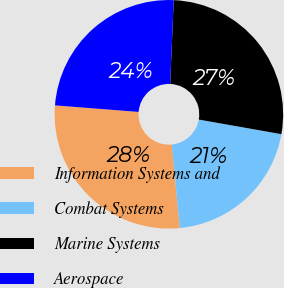Convert chart. <chart><loc_0><loc_0><loc_500><loc_500><pie_chart><fcel>Information Systems and<fcel>Combat Systems<fcel>Marine Systems<fcel>Aerospace<nl><fcel>27.77%<fcel>20.69%<fcel>27.11%<fcel>24.43%<nl></chart> 